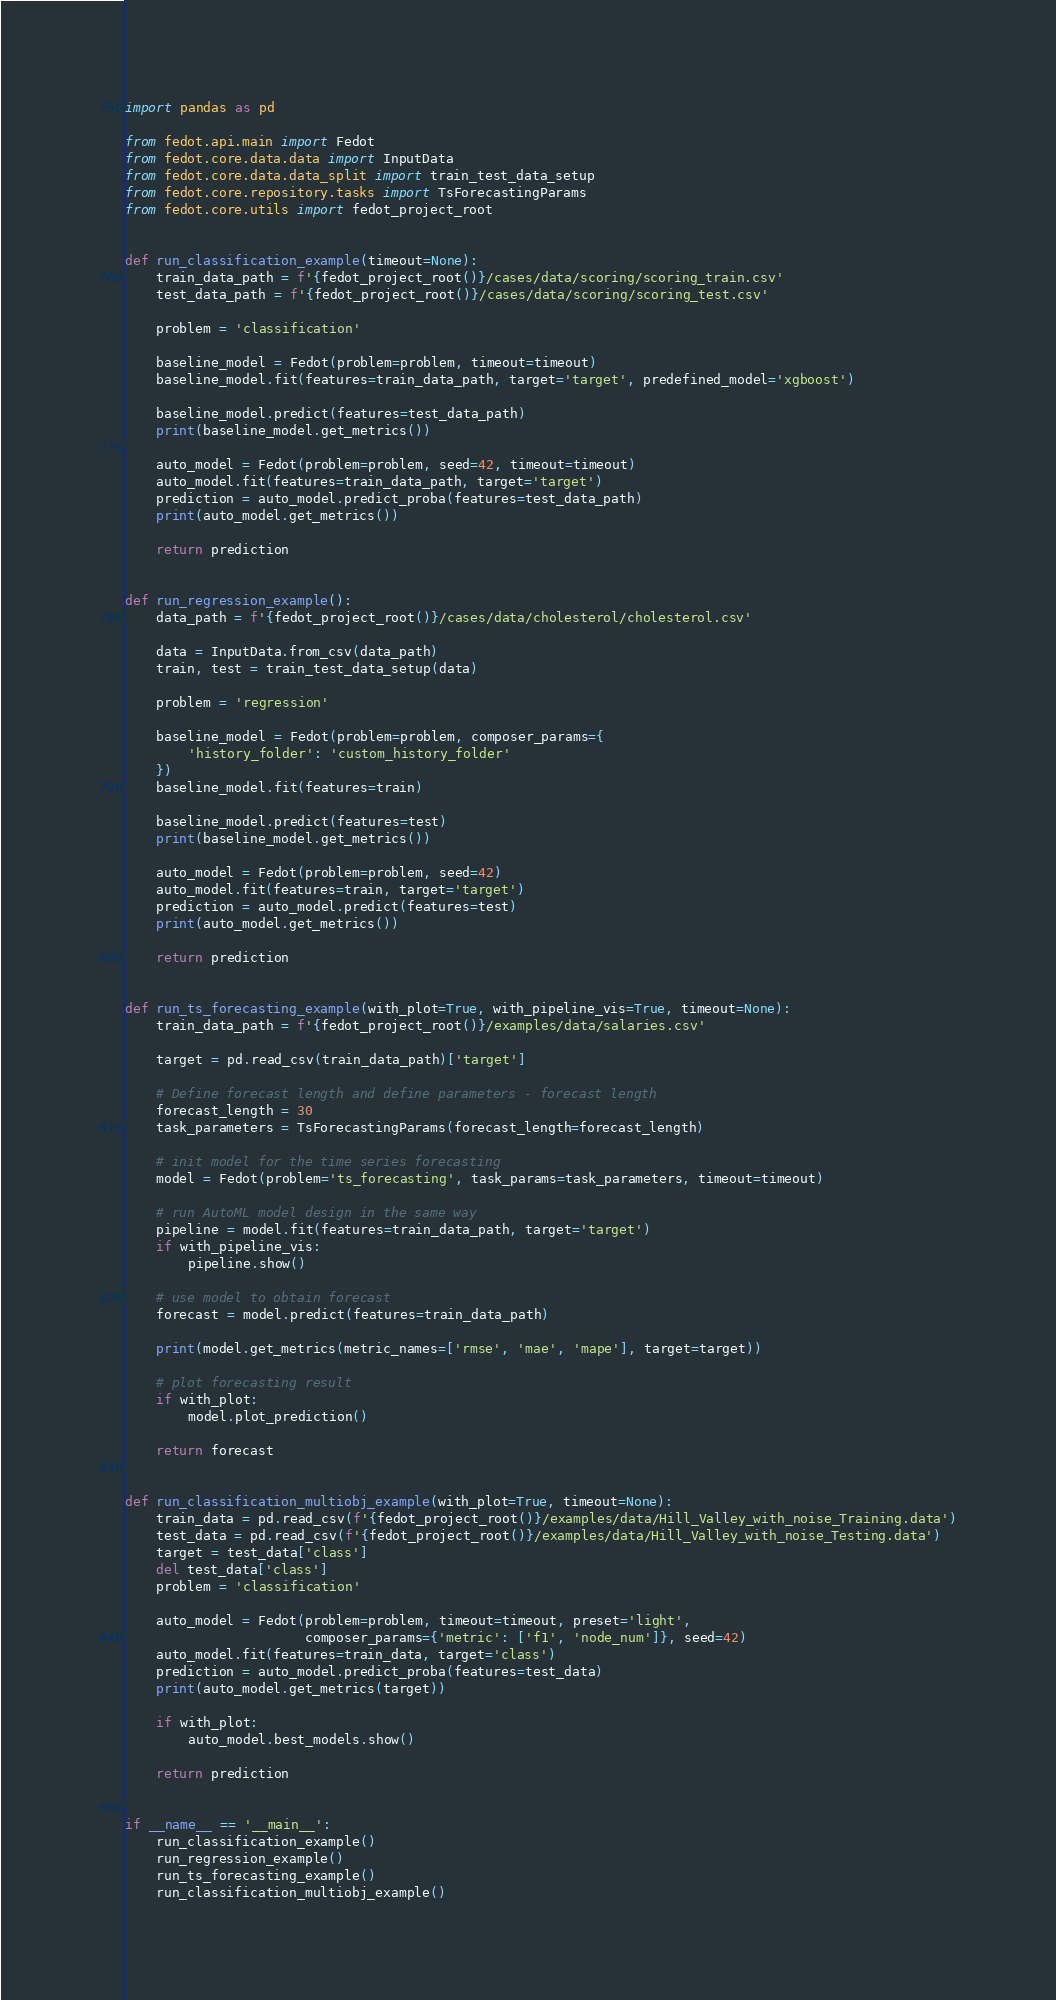Convert code to text. <code><loc_0><loc_0><loc_500><loc_500><_Python_>import pandas as pd

from fedot.api.main import Fedot
from fedot.core.data.data import InputData
from fedot.core.data.data_split import train_test_data_setup
from fedot.core.repository.tasks import TsForecastingParams
from fedot.core.utils import fedot_project_root


def run_classification_example(timeout=None):
    train_data_path = f'{fedot_project_root()}/cases/data/scoring/scoring_train.csv'
    test_data_path = f'{fedot_project_root()}/cases/data/scoring/scoring_test.csv'

    problem = 'classification'

    baseline_model = Fedot(problem=problem, timeout=timeout)
    baseline_model.fit(features=train_data_path, target='target', predefined_model='xgboost')

    baseline_model.predict(features=test_data_path)
    print(baseline_model.get_metrics())

    auto_model = Fedot(problem=problem, seed=42, timeout=timeout)
    auto_model.fit(features=train_data_path, target='target')
    prediction = auto_model.predict_proba(features=test_data_path)
    print(auto_model.get_metrics())

    return prediction


def run_regression_example():
    data_path = f'{fedot_project_root()}/cases/data/cholesterol/cholesterol.csv'

    data = InputData.from_csv(data_path)
    train, test = train_test_data_setup(data)

    problem = 'regression'

    baseline_model = Fedot(problem=problem, composer_params={
        'history_folder': 'custom_history_folder'
    })
    baseline_model.fit(features=train)

    baseline_model.predict(features=test)
    print(baseline_model.get_metrics())

    auto_model = Fedot(problem=problem, seed=42)
    auto_model.fit(features=train, target='target')
    prediction = auto_model.predict(features=test)
    print(auto_model.get_metrics())

    return prediction


def run_ts_forecasting_example(with_plot=True, with_pipeline_vis=True, timeout=None):
    train_data_path = f'{fedot_project_root()}/examples/data/salaries.csv'

    target = pd.read_csv(train_data_path)['target']

    # Define forecast length and define parameters - forecast length
    forecast_length = 30
    task_parameters = TsForecastingParams(forecast_length=forecast_length)

    # init model for the time series forecasting
    model = Fedot(problem='ts_forecasting', task_params=task_parameters, timeout=timeout)

    # run AutoML model design in the same way
    pipeline = model.fit(features=train_data_path, target='target')
    if with_pipeline_vis:
        pipeline.show()

    # use model to obtain forecast
    forecast = model.predict(features=train_data_path)

    print(model.get_metrics(metric_names=['rmse', 'mae', 'mape'], target=target))

    # plot forecasting result
    if with_plot:
        model.plot_prediction()

    return forecast


def run_classification_multiobj_example(with_plot=True, timeout=None):
    train_data = pd.read_csv(f'{fedot_project_root()}/examples/data/Hill_Valley_with_noise_Training.data')
    test_data = pd.read_csv(f'{fedot_project_root()}/examples/data/Hill_Valley_with_noise_Testing.data')
    target = test_data['class']
    del test_data['class']
    problem = 'classification'

    auto_model = Fedot(problem=problem, timeout=timeout, preset='light',
                       composer_params={'metric': ['f1', 'node_num']}, seed=42)
    auto_model.fit(features=train_data, target='class')
    prediction = auto_model.predict_proba(features=test_data)
    print(auto_model.get_metrics(target))

    if with_plot:
        auto_model.best_models.show()

    return prediction


if __name__ == '__main__':
    run_classification_example()
    run_regression_example()
    run_ts_forecasting_example()
    run_classification_multiobj_example()
</code> 